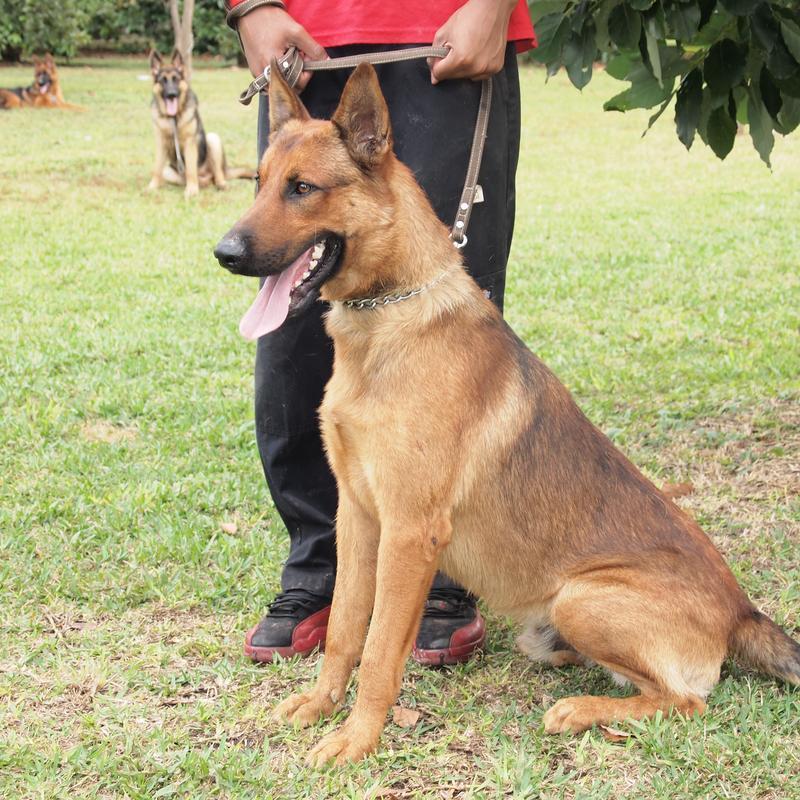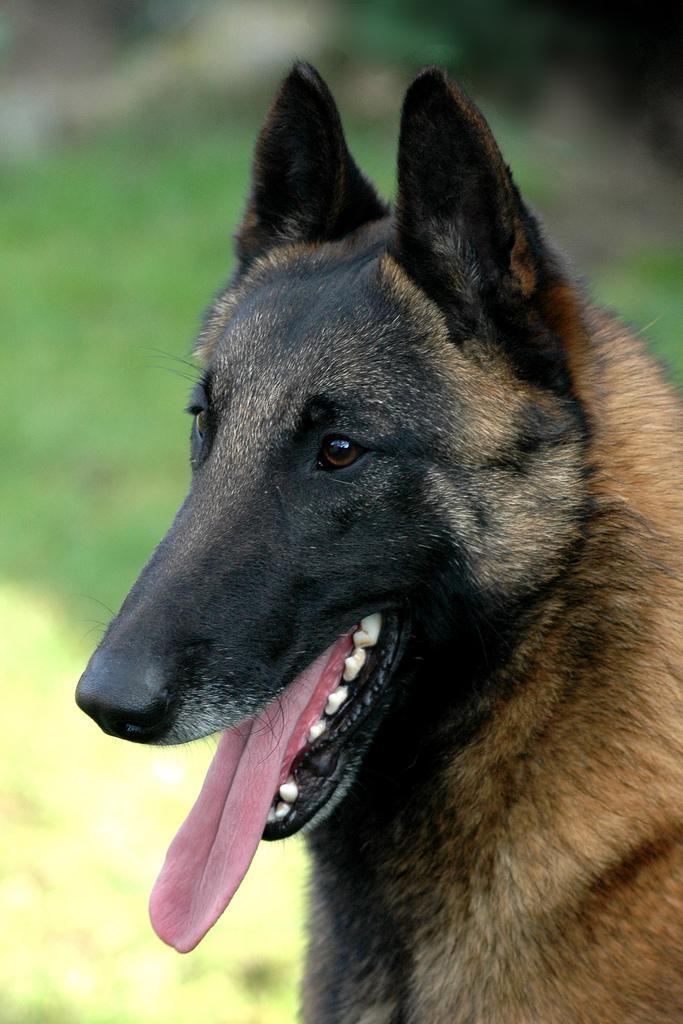The first image is the image on the left, the second image is the image on the right. For the images shown, is this caption "At least one animal has no visible collar or leash." true? Answer yes or no. Yes. 